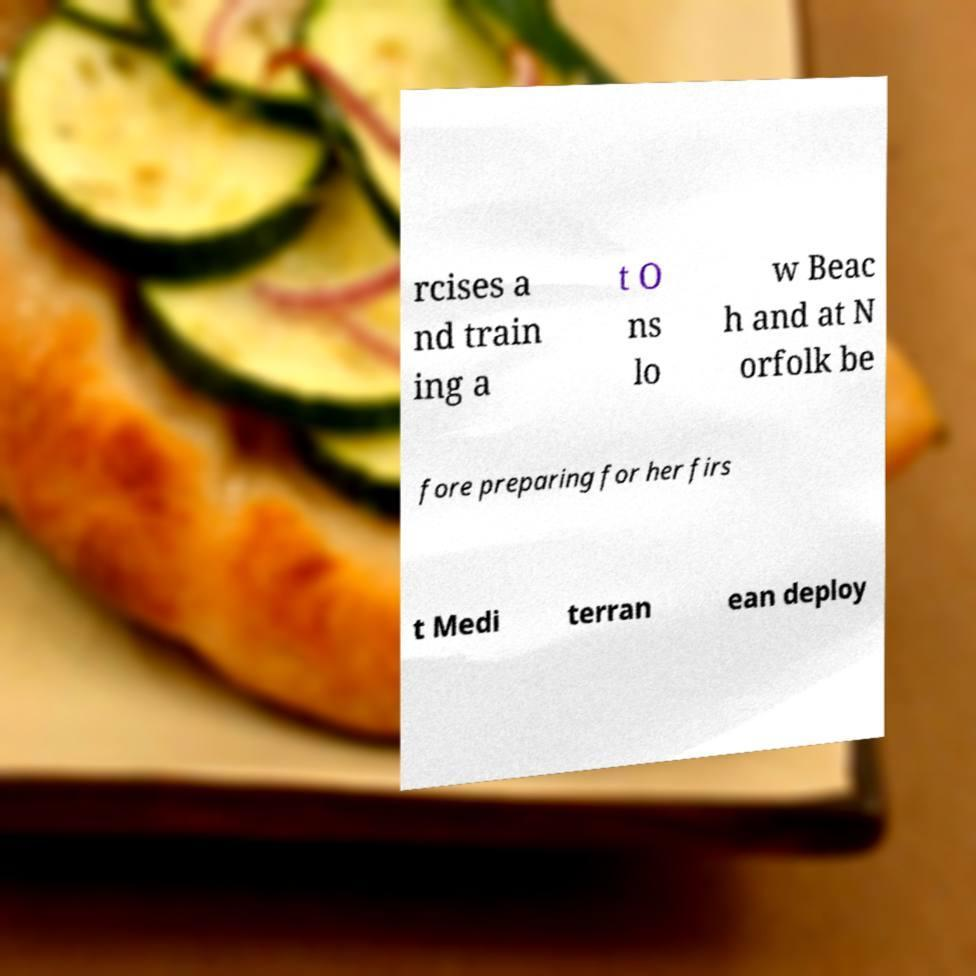What messages or text are displayed in this image? I need them in a readable, typed format. rcises a nd train ing a t O ns lo w Beac h and at N orfolk be fore preparing for her firs t Medi terran ean deploy 